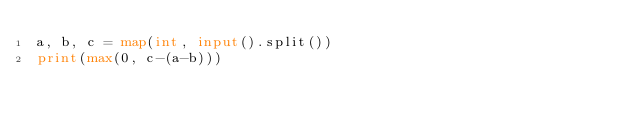<code> <loc_0><loc_0><loc_500><loc_500><_Python_>a, b, c = map(int, input().split())
print(max(0, c-(a-b)))
</code> 